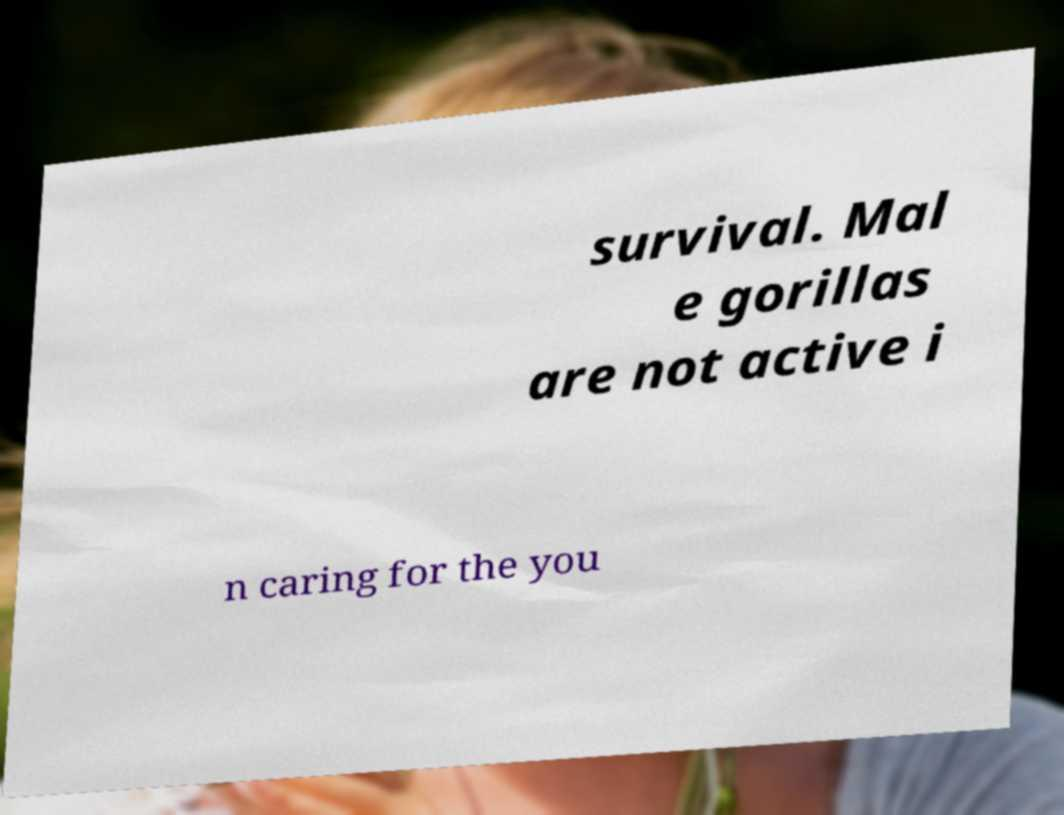Could you assist in decoding the text presented in this image and type it out clearly? survival. Mal e gorillas are not active i n caring for the you 